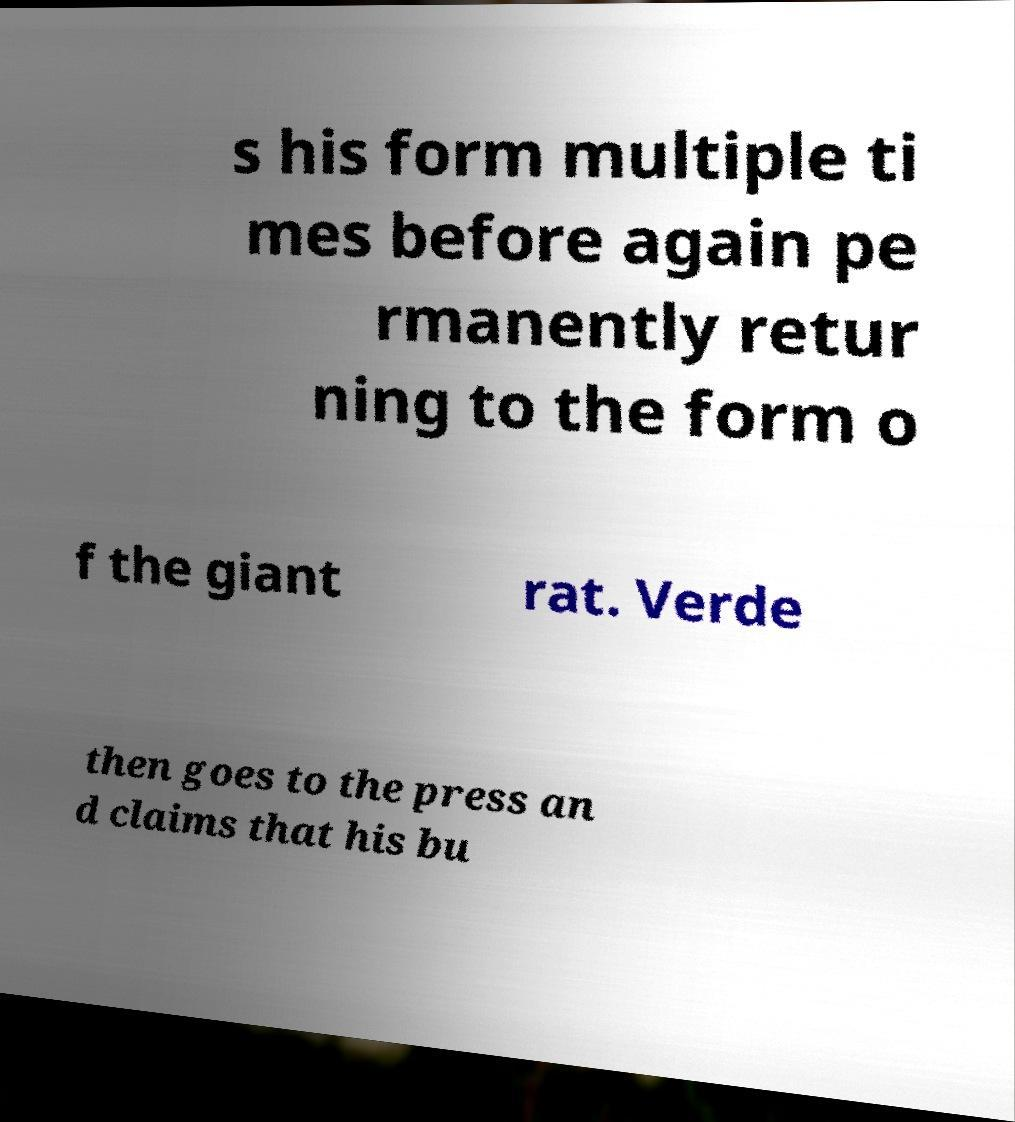Can you accurately transcribe the text from the provided image for me? s his form multiple ti mes before again pe rmanently retur ning to the form o f the giant rat. Verde then goes to the press an d claims that his bu 